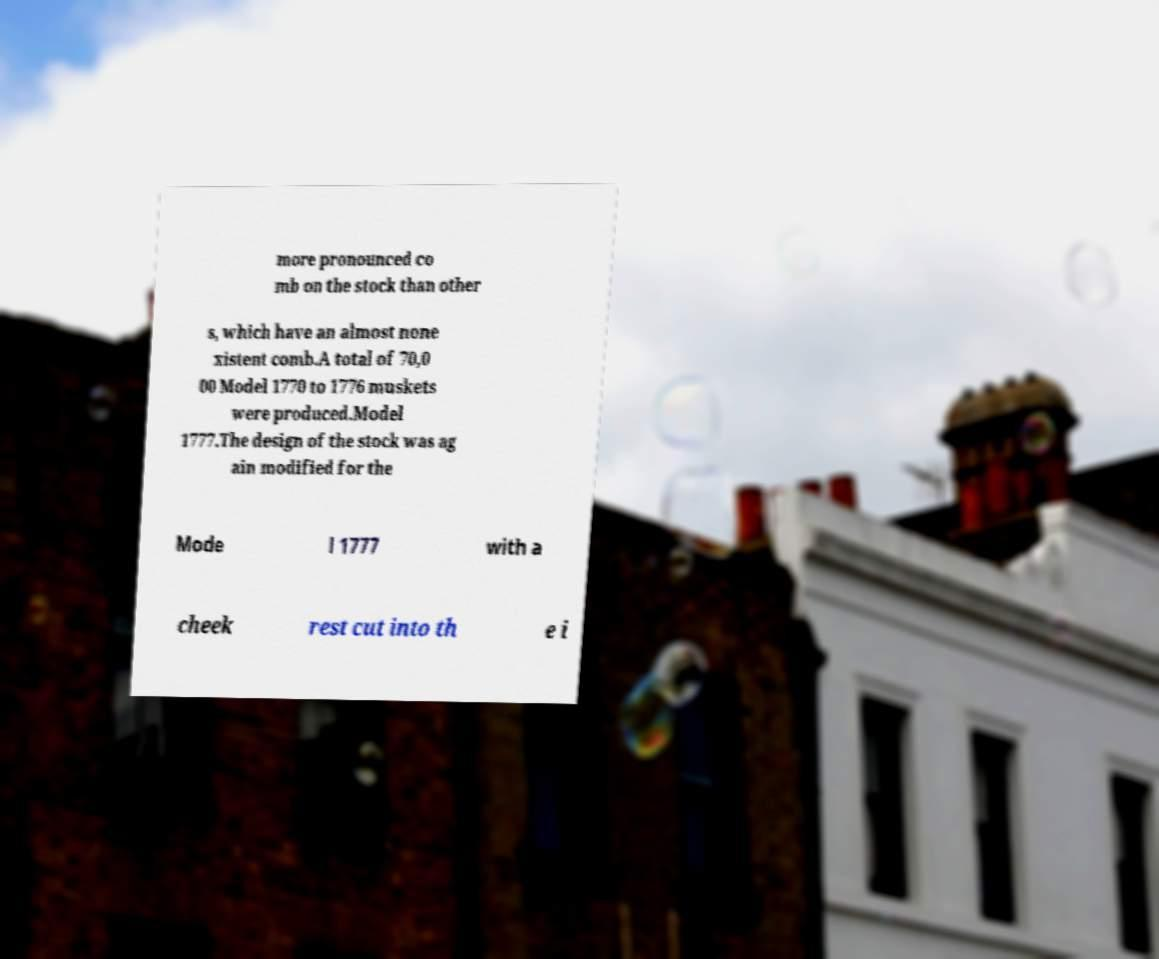Can you read and provide the text displayed in the image?This photo seems to have some interesting text. Can you extract and type it out for me? more pronounced co mb on the stock than other s, which have an almost none xistent comb.A total of 70,0 00 Model 1770 to 1776 muskets were produced.Model 1777.The design of the stock was ag ain modified for the Mode l 1777 with a cheek rest cut into th e i 